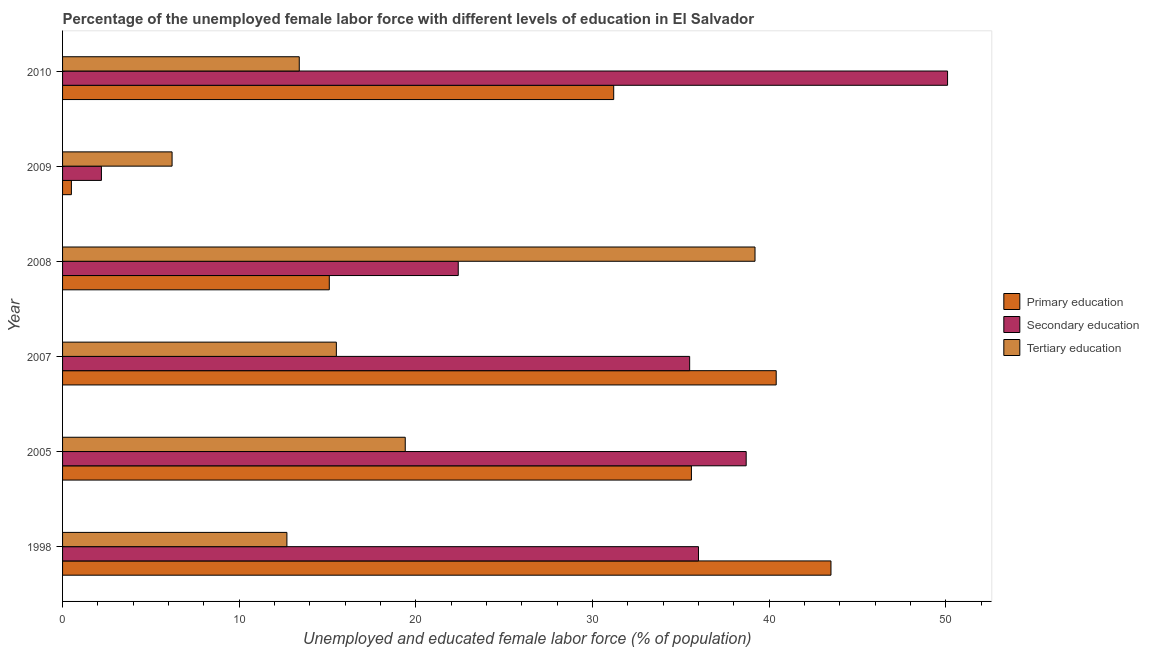Are the number of bars per tick equal to the number of legend labels?
Your response must be concise. Yes. How many bars are there on the 3rd tick from the top?
Provide a succinct answer. 3. What is the label of the 4th group of bars from the top?
Offer a very short reply. 2007. Across all years, what is the maximum percentage of female labor force who received tertiary education?
Provide a short and direct response. 39.2. Across all years, what is the minimum percentage of female labor force who received secondary education?
Provide a succinct answer. 2.2. What is the total percentage of female labor force who received primary education in the graph?
Your answer should be very brief. 166.3. What is the difference between the percentage of female labor force who received secondary education in 2010 and the percentage of female labor force who received tertiary education in 2005?
Make the answer very short. 30.7. What is the average percentage of female labor force who received tertiary education per year?
Your answer should be compact. 17.73. What is the ratio of the percentage of female labor force who received tertiary education in 1998 to that in 2008?
Your answer should be compact. 0.32. Is the percentage of female labor force who received tertiary education in 2009 less than that in 2010?
Give a very brief answer. Yes. Is the difference between the percentage of female labor force who received tertiary education in 2005 and 2008 greater than the difference between the percentage of female labor force who received primary education in 2005 and 2008?
Your response must be concise. No. What is the difference between the highest and the second highest percentage of female labor force who received tertiary education?
Offer a very short reply. 19.8. In how many years, is the percentage of female labor force who received tertiary education greater than the average percentage of female labor force who received tertiary education taken over all years?
Provide a succinct answer. 2. Is the sum of the percentage of female labor force who received primary education in 2008 and 2009 greater than the maximum percentage of female labor force who received tertiary education across all years?
Your answer should be compact. No. What does the 2nd bar from the bottom in 2005 represents?
Make the answer very short. Secondary education. Is it the case that in every year, the sum of the percentage of female labor force who received primary education and percentage of female labor force who received secondary education is greater than the percentage of female labor force who received tertiary education?
Your response must be concise. No. Are all the bars in the graph horizontal?
Give a very brief answer. Yes. What is the difference between two consecutive major ticks on the X-axis?
Your answer should be compact. 10. Are the values on the major ticks of X-axis written in scientific E-notation?
Make the answer very short. No. Does the graph contain any zero values?
Your answer should be very brief. No. Does the graph contain grids?
Provide a succinct answer. No. How many legend labels are there?
Your answer should be compact. 3. How are the legend labels stacked?
Your response must be concise. Vertical. What is the title of the graph?
Your response must be concise. Percentage of the unemployed female labor force with different levels of education in El Salvador. What is the label or title of the X-axis?
Keep it short and to the point. Unemployed and educated female labor force (% of population). What is the label or title of the Y-axis?
Provide a short and direct response. Year. What is the Unemployed and educated female labor force (% of population) in Primary education in 1998?
Your answer should be very brief. 43.5. What is the Unemployed and educated female labor force (% of population) of Tertiary education in 1998?
Your answer should be compact. 12.7. What is the Unemployed and educated female labor force (% of population) of Primary education in 2005?
Your answer should be very brief. 35.6. What is the Unemployed and educated female labor force (% of population) of Secondary education in 2005?
Your answer should be compact. 38.7. What is the Unemployed and educated female labor force (% of population) in Tertiary education in 2005?
Ensure brevity in your answer.  19.4. What is the Unemployed and educated female labor force (% of population) in Primary education in 2007?
Your answer should be compact. 40.4. What is the Unemployed and educated female labor force (% of population) of Secondary education in 2007?
Your answer should be very brief. 35.5. What is the Unemployed and educated female labor force (% of population) in Tertiary education in 2007?
Your answer should be very brief. 15.5. What is the Unemployed and educated female labor force (% of population) of Primary education in 2008?
Your answer should be very brief. 15.1. What is the Unemployed and educated female labor force (% of population) in Secondary education in 2008?
Your answer should be very brief. 22.4. What is the Unemployed and educated female labor force (% of population) in Tertiary education in 2008?
Provide a short and direct response. 39.2. What is the Unemployed and educated female labor force (% of population) of Primary education in 2009?
Ensure brevity in your answer.  0.5. What is the Unemployed and educated female labor force (% of population) of Secondary education in 2009?
Keep it short and to the point. 2.2. What is the Unemployed and educated female labor force (% of population) of Tertiary education in 2009?
Your response must be concise. 6.2. What is the Unemployed and educated female labor force (% of population) in Primary education in 2010?
Provide a succinct answer. 31.2. What is the Unemployed and educated female labor force (% of population) of Secondary education in 2010?
Your answer should be very brief. 50.1. What is the Unemployed and educated female labor force (% of population) in Tertiary education in 2010?
Offer a very short reply. 13.4. Across all years, what is the maximum Unemployed and educated female labor force (% of population) in Primary education?
Your answer should be compact. 43.5. Across all years, what is the maximum Unemployed and educated female labor force (% of population) in Secondary education?
Ensure brevity in your answer.  50.1. Across all years, what is the maximum Unemployed and educated female labor force (% of population) of Tertiary education?
Your response must be concise. 39.2. Across all years, what is the minimum Unemployed and educated female labor force (% of population) of Secondary education?
Provide a short and direct response. 2.2. Across all years, what is the minimum Unemployed and educated female labor force (% of population) in Tertiary education?
Provide a short and direct response. 6.2. What is the total Unemployed and educated female labor force (% of population) in Primary education in the graph?
Keep it short and to the point. 166.3. What is the total Unemployed and educated female labor force (% of population) in Secondary education in the graph?
Your answer should be compact. 184.9. What is the total Unemployed and educated female labor force (% of population) of Tertiary education in the graph?
Offer a terse response. 106.4. What is the difference between the Unemployed and educated female labor force (% of population) in Primary education in 1998 and that in 2005?
Offer a very short reply. 7.9. What is the difference between the Unemployed and educated female labor force (% of population) of Tertiary education in 1998 and that in 2005?
Provide a succinct answer. -6.7. What is the difference between the Unemployed and educated female labor force (% of population) in Primary education in 1998 and that in 2007?
Keep it short and to the point. 3.1. What is the difference between the Unemployed and educated female labor force (% of population) in Secondary education in 1998 and that in 2007?
Your answer should be very brief. 0.5. What is the difference between the Unemployed and educated female labor force (% of population) in Tertiary education in 1998 and that in 2007?
Your answer should be very brief. -2.8. What is the difference between the Unemployed and educated female labor force (% of population) of Primary education in 1998 and that in 2008?
Your response must be concise. 28.4. What is the difference between the Unemployed and educated female labor force (% of population) in Tertiary education in 1998 and that in 2008?
Provide a succinct answer. -26.5. What is the difference between the Unemployed and educated female labor force (% of population) in Secondary education in 1998 and that in 2009?
Offer a terse response. 33.8. What is the difference between the Unemployed and educated female labor force (% of population) in Tertiary education in 1998 and that in 2009?
Provide a short and direct response. 6.5. What is the difference between the Unemployed and educated female labor force (% of population) of Secondary education in 1998 and that in 2010?
Keep it short and to the point. -14.1. What is the difference between the Unemployed and educated female labor force (% of population) in Tertiary education in 1998 and that in 2010?
Your answer should be compact. -0.7. What is the difference between the Unemployed and educated female labor force (% of population) in Secondary education in 2005 and that in 2007?
Your answer should be very brief. 3.2. What is the difference between the Unemployed and educated female labor force (% of population) in Tertiary education in 2005 and that in 2008?
Offer a very short reply. -19.8. What is the difference between the Unemployed and educated female labor force (% of population) in Primary education in 2005 and that in 2009?
Keep it short and to the point. 35.1. What is the difference between the Unemployed and educated female labor force (% of population) of Secondary education in 2005 and that in 2009?
Give a very brief answer. 36.5. What is the difference between the Unemployed and educated female labor force (% of population) of Tertiary education in 2005 and that in 2009?
Ensure brevity in your answer.  13.2. What is the difference between the Unemployed and educated female labor force (% of population) of Primary education in 2005 and that in 2010?
Your response must be concise. 4.4. What is the difference between the Unemployed and educated female labor force (% of population) in Tertiary education in 2005 and that in 2010?
Offer a terse response. 6. What is the difference between the Unemployed and educated female labor force (% of population) of Primary education in 2007 and that in 2008?
Give a very brief answer. 25.3. What is the difference between the Unemployed and educated female labor force (% of population) of Secondary education in 2007 and that in 2008?
Your response must be concise. 13.1. What is the difference between the Unemployed and educated female labor force (% of population) in Tertiary education in 2007 and that in 2008?
Make the answer very short. -23.7. What is the difference between the Unemployed and educated female labor force (% of population) in Primary education in 2007 and that in 2009?
Provide a succinct answer. 39.9. What is the difference between the Unemployed and educated female labor force (% of population) of Secondary education in 2007 and that in 2009?
Make the answer very short. 33.3. What is the difference between the Unemployed and educated female labor force (% of population) of Tertiary education in 2007 and that in 2009?
Ensure brevity in your answer.  9.3. What is the difference between the Unemployed and educated female labor force (% of population) of Primary education in 2007 and that in 2010?
Offer a very short reply. 9.2. What is the difference between the Unemployed and educated female labor force (% of population) in Secondary education in 2007 and that in 2010?
Provide a succinct answer. -14.6. What is the difference between the Unemployed and educated female labor force (% of population) in Tertiary education in 2007 and that in 2010?
Keep it short and to the point. 2.1. What is the difference between the Unemployed and educated female labor force (% of population) of Secondary education in 2008 and that in 2009?
Provide a short and direct response. 20.2. What is the difference between the Unemployed and educated female labor force (% of population) of Tertiary education in 2008 and that in 2009?
Provide a succinct answer. 33. What is the difference between the Unemployed and educated female labor force (% of population) in Primary education in 2008 and that in 2010?
Ensure brevity in your answer.  -16.1. What is the difference between the Unemployed and educated female labor force (% of population) in Secondary education in 2008 and that in 2010?
Ensure brevity in your answer.  -27.7. What is the difference between the Unemployed and educated female labor force (% of population) of Tertiary education in 2008 and that in 2010?
Keep it short and to the point. 25.8. What is the difference between the Unemployed and educated female labor force (% of population) of Primary education in 2009 and that in 2010?
Provide a short and direct response. -30.7. What is the difference between the Unemployed and educated female labor force (% of population) of Secondary education in 2009 and that in 2010?
Your answer should be compact. -47.9. What is the difference between the Unemployed and educated female labor force (% of population) in Tertiary education in 2009 and that in 2010?
Give a very brief answer. -7.2. What is the difference between the Unemployed and educated female labor force (% of population) of Primary education in 1998 and the Unemployed and educated female labor force (% of population) of Tertiary education in 2005?
Make the answer very short. 24.1. What is the difference between the Unemployed and educated female labor force (% of population) in Secondary education in 1998 and the Unemployed and educated female labor force (% of population) in Tertiary education in 2005?
Make the answer very short. 16.6. What is the difference between the Unemployed and educated female labor force (% of population) of Primary education in 1998 and the Unemployed and educated female labor force (% of population) of Secondary education in 2008?
Your response must be concise. 21.1. What is the difference between the Unemployed and educated female labor force (% of population) of Primary education in 1998 and the Unemployed and educated female labor force (% of population) of Secondary education in 2009?
Your answer should be compact. 41.3. What is the difference between the Unemployed and educated female labor force (% of population) of Primary education in 1998 and the Unemployed and educated female labor force (% of population) of Tertiary education in 2009?
Your answer should be very brief. 37.3. What is the difference between the Unemployed and educated female labor force (% of population) in Secondary education in 1998 and the Unemployed and educated female labor force (% of population) in Tertiary education in 2009?
Your response must be concise. 29.8. What is the difference between the Unemployed and educated female labor force (% of population) in Primary education in 1998 and the Unemployed and educated female labor force (% of population) in Tertiary education in 2010?
Offer a very short reply. 30.1. What is the difference between the Unemployed and educated female labor force (% of population) of Secondary education in 1998 and the Unemployed and educated female labor force (% of population) of Tertiary education in 2010?
Give a very brief answer. 22.6. What is the difference between the Unemployed and educated female labor force (% of population) of Primary education in 2005 and the Unemployed and educated female labor force (% of population) of Secondary education in 2007?
Give a very brief answer. 0.1. What is the difference between the Unemployed and educated female labor force (% of population) of Primary education in 2005 and the Unemployed and educated female labor force (% of population) of Tertiary education in 2007?
Make the answer very short. 20.1. What is the difference between the Unemployed and educated female labor force (% of population) of Secondary education in 2005 and the Unemployed and educated female labor force (% of population) of Tertiary education in 2007?
Provide a succinct answer. 23.2. What is the difference between the Unemployed and educated female labor force (% of population) in Primary education in 2005 and the Unemployed and educated female labor force (% of population) in Secondary education in 2008?
Your answer should be compact. 13.2. What is the difference between the Unemployed and educated female labor force (% of population) in Primary education in 2005 and the Unemployed and educated female labor force (% of population) in Tertiary education in 2008?
Offer a very short reply. -3.6. What is the difference between the Unemployed and educated female labor force (% of population) in Primary education in 2005 and the Unemployed and educated female labor force (% of population) in Secondary education in 2009?
Your answer should be very brief. 33.4. What is the difference between the Unemployed and educated female labor force (% of population) in Primary education in 2005 and the Unemployed and educated female labor force (% of population) in Tertiary education in 2009?
Ensure brevity in your answer.  29.4. What is the difference between the Unemployed and educated female labor force (% of population) in Secondary education in 2005 and the Unemployed and educated female labor force (% of population) in Tertiary education in 2009?
Your answer should be very brief. 32.5. What is the difference between the Unemployed and educated female labor force (% of population) in Primary education in 2005 and the Unemployed and educated female labor force (% of population) in Tertiary education in 2010?
Keep it short and to the point. 22.2. What is the difference between the Unemployed and educated female labor force (% of population) in Secondary education in 2005 and the Unemployed and educated female labor force (% of population) in Tertiary education in 2010?
Offer a very short reply. 25.3. What is the difference between the Unemployed and educated female labor force (% of population) in Primary education in 2007 and the Unemployed and educated female labor force (% of population) in Secondary education in 2008?
Ensure brevity in your answer.  18. What is the difference between the Unemployed and educated female labor force (% of population) of Primary education in 2007 and the Unemployed and educated female labor force (% of population) of Secondary education in 2009?
Your answer should be very brief. 38.2. What is the difference between the Unemployed and educated female labor force (% of population) in Primary education in 2007 and the Unemployed and educated female labor force (% of population) in Tertiary education in 2009?
Provide a short and direct response. 34.2. What is the difference between the Unemployed and educated female labor force (% of population) in Secondary education in 2007 and the Unemployed and educated female labor force (% of population) in Tertiary education in 2009?
Offer a terse response. 29.3. What is the difference between the Unemployed and educated female labor force (% of population) of Primary education in 2007 and the Unemployed and educated female labor force (% of population) of Secondary education in 2010?
Ensure brevity in your answer.  -9.7. What is the difference between the Unemployed and educated female labor force (% of population) in Primary education in 2007 and the Unemployed and educated female labor force (% of population) in Tertiary education in 2010?
Offer a terse response. 27. What is the difference between the Unemployed and educated female labor force (% of population) of Secondary education in 2007 and the Unemployed and educated female labor force (% of population) of Tertiary education in 2010?
Provide a short and direct response. 22.1. What is the difference between the Unemployed and educated female labor force (% of population) of Primary education in 2008 and the Unemployed and educated female labor force (% of population) of Tertiary education in 2009?
Keep it short and to the point. 8.9. What is the difference between the Unemployed and educated female labor force (% of population) in Primary education in 2008 and the Unemployed and educated female labor force (% of population) in Secondary education in 2010?
Give a very brief answer. -35. What is the difference between the Unemployed and educated female labor force (% of population) of Primary education in 2008 and the Unemployed and educated female labor force (% of population) of Tertiary education in 2010?
Keep it short and to the point. 1.7. What is the difference between the Unemployed and educated female labor force (% of population) of Primary education in 2009 and the Unemployed and educated female labor force (% of population) of Secondary education in 2010?
Keep it short and to the point. -49.6. What is the average Unemployed and educated female labor force (% of population) of Primary education per year?
Offer a terse response. 27.72. What is the average Unemployed and educated female labor force (% of population) in Secondary education per year?
Ensure brevity in your answer.  30.82. What is the average Unemployed and educated female labor force (% of population) of Tertiary education per year?
Ensure brevity in your answer.  17.73. In the year 1998, what is the difference between the Unemployed and educated female labor force (% of population) of Primary education and Unemployed and educated female labor force (% of population) of Secondary education?
Provide a short and direct response. 7.5. In the year 1998, what is the difference between the Unemployed and educated female labor force (% of population) in Primary education and Unemployed and educated female labor force (% of population) in Tertiary education?
Offer a very short reply. 30.8. In the year 1998, what is the difference between the Unemployed and educated female labor force (% of population) of Secondary education and Unemployed and educated female labor force (% of population) of Tertiary education?
Provide a succinct answer. 23.3. In the year 2005, what is the difference between the Unemployed and educated female labor force (% of population) in Secondary education and Unemployed and educated female labor force (% of population) in Tertiary education?
Keep it short and to the point. 19.3. In the year 2007, what is the difference between the Unemployed and educated female labor force (% of population) of Primary education and Unemployed and educated female labor force (% of population) of Secondary education?
Ensure brevity in your answer.  4.9. In the year 2007, what is the difference between the Unemployed and educated female labor force (% of population) of Primary education and Unemployed and educated female labor force (% of population) of Tertiary education?
Give a very brief answer. 24.9. In the year 2008, what is the difference between the Unemployed and educated female labor force (% of population) of Primary education and Unemployed and educated female labor force (% of population) of Secondary education?
Your answer should be compact. -7.3. In the year 2008, what is the difference between the Unemployed and educated female labor force (% of population) in Primary education and Unemployed and educated female labor force (% of population) in Tertiary education?
Keep it short and to the point. -24.1. In the year 2008, what is the difference between the Unemployed and educated female labor force (% of population) in Secondary education and Unemployed and educated female labor force (% of population) in Tertiary education?
Provide a succinct answer. -16.8. In the year 2009, what is the difference between the Unemployed and educated female labor force (% of population) in Secondary education and Unemployed and educated female labor force (% of population) in Tertiary education?
Offer a terse response. -4. In the year 2010, what is the difference between the Unemployed and educated female labor force (% of population) of Primary education and Unemployed and educated female labor force (% of population) of Secondary education?
Ensure brevity in your answer.  -18.9. In the year 2010, what is the difference between the Unemployed and educated female labor force (% of population) of Secondary education and Unemployed and educated female labor force (% of population) of Tertiary education?
Your answer should be compact. 36.7. What is the ratio of the Unemployed and educated female labor force (% of population) in Primary education in 1998 to that in 2005?
Your answer should be very brief. 1.22. What is the ratio of the Unemployed and educated female labor force (% of population) of Secondary education in 1998 to that in 2005?
Ensure brevity in your answer.  0.93. What is the ratio of the Unemployed and educated female labor force (% of population) in Tertiary education in 1998 to that in 2005?
Keep it short and to the point. 0.65. What is the ratio of the Unemployed and educated female labor force (% of population) in Primary education in 1998 to that in 2007?
Your response must be concise. 1.08. What is the ratio of the Unemployed and educated female labor force (% of population) of Secondary education in 1998 to that in 2007?
Offer a very short reply. 1.01. What is the ratio of the Unemployed and educated female labor force (% of population) in Tertiary education in 1998 to that in 2007?
Keep it short and to the point. 0.82. What is the ratio of the Unemployed and educated female labor force (% of population) of Primary education in 1998 to that in 2008?
Keep it short and to the point. 2.88. What is the ratio of the Unemployed and educated female labor force (% of population) of Secondary education in 1998 to that in 2008?
Give a very brief answer. 1.61. What is the ratio of the Unemployed and educated female labor force (% of population) of Tertiary education in 1998 to that in 2008?
Make the answer very short. 0.32. What is the ratio of the Unemployed and educated female labor force (% of population) in Secondary education in 1998 to that in 2009?
Provide a short and direct response. 16.36. What is the ratio of the Unemployed and educated female labor force (% of population) in Tertiary education in 1998 to that in 2009?
Your answer should be compact. 2.05. What is the ratio of the Unemployed and educated female labor force (% of population) of Primary education in 1998 to that in 2010?
Ensure brevity in your answer.  1.39. What is the ratio of the Unemployed and educated female labor force (% of population) of Secondary education in 1998 to that in 2010?
Make the answer very short. 0.72. What is the ratio of the Unemployed and educated female labor force (% of population) in Tertiary education in 1998 to that in 2010?
Provide a succinct answer. 0.95. What is the ratio of the Unemployed and educated female labor force (% of population) in Primary education in 2005 to that in 2007?
Give a very brief answer. 0.88. What is the ratio of the Unemployed and educated female labor force (% of population) in Secondary education in 2005 to that in 2007?
Your response must be concise. 1.09. What is the ratio of the Unemployed and educated female labor force (% of population) in Tertiary education in 2005 to that in 2007?
Offer a very short reply. 1.25. What is the ratio of the Unemployed and educated female labor force (% of population) of Primary education in 2005 to that in 2008?
Offer a very short reply. 2.36. What is the ratio of the Unemployed and educated female labor force (% of population) of Secondary education in 2005 to that in 2008?
Offer a terse response. 1.73. What is the ratio of the Unemployed and educated female labor force (% of population) in Tertiary education in 2005 to that in 2008?
Ensure brevity in your answer.  0.49. What is the ratio of the Unemployed and educated female labor force (% of population) of Primary education in 2005 to that in 2009?
Keep it short and to the point. 71.2. What is the ratio of the Unemployed and educated female labor force (% of population) of Secondary education in 2005 to that in 2009?
Offer a terse response. 17.59. What is the ratio of the Unemployed and educated female labor force (% of population) of Tertiary education in 2005 to that in 2009?
Make the answer very short. 3.13. What is the ratio of the Unemployed and educated female labor force (% of population) in Primary education in 2005 to that in 2010?
Your response must be concise. 1.14. What is the ratio of the Unemployed and educated female labor force (% of population) in Secondary education in 2005 to that in 2010?
Give a very brief answer. 0.77. What is the ratio of the Unemployed and educated female labor force (% of population) in Tertiary education in 2005 to that in 2010?
Keep it short and to the point. 1.45. What is the ratio of the Unemployed and educated female labor force (% of population) in Primary education in 2007 to that in 2008?
Your answer should be compact. 2.68. What is the ratio of the Unemployed and educated female labor force (% of population) in Secondary education in 2007 to that in 2008?
Offer a terse response. 1.58. What is the ratio of the Unemployed and educated female labor force (% of population) in Tertiary education in 2007 to that in 2008?
Give a very brief answer. 0.4. What is the ratio of the Unemployed and educated female labor force (% of population) in Primary education in 2007 to that in 2009?
Your answer should be very brief. 80.8. What is the ratio of the Unemployed and educated female labor force (% of population) of Secondary education in 2007 to that in 2009?
Provide a short and direct response. 16.14. What is the ratio of the Unemployed and educated female labor force (% of population) in Primary education in 2007 to that in 2010?
Ensure brevity in your answer.  1.29. What is the ratio of the Unemployed and educated female labor force (% of population) in Secondary education in 2007 to that in 2010?
Make the answer very short. 0.71. What is the ratio of the Unemployed and educated female labor force (% of population) in Tertiary education in 2007 to that in 2010?
Make the answer very short. 1.16. What is the ratio of the Unemployed and educated female labor force (% of population) of Primary education in 2008 to that in 2009?
Provide a short and direct response. 30.2. What is the ratio of the Unemployed and educated female labor force (% of population) of Secondary education in 2008 to that in 2009?
Your answer should be very brief. 10.18. What is the ratio of the Unemployed and educated female labor force (% of population) in Tertiary education in 2008 to that in 2009?
Your answer should be very brief. 6.32. What is the ratio of the Unemployed and educated female labor force (% of population) of Primary education in 2008 to that in 2010?
Keep it short and to the point. 0.48. What is the ratio of the Unemployed and educated female labor force (% of population) in Secondary education in 2008 to that in 2010?
Your answer should be very brief. 0.45. What is the ratio of the Unemployed and educated female labor force (% of population) of Tertiary education in 2008 to that in 2010?
Offer a terse response. 2.93. What is the ratio of the Unemployed and educated female labor force (% of population) of Primary education in 2009 to that in 2010?
Offer a very short reply. 0.02. What is the ratio of the Unemployed and educated female labor force (% of population) of Secondary education in 2009 to that in 2010?
Offer a very short reply. 0.04. What is the ratio of the Unemployed and educated female labor force (% of population) in Tertiary education in 2009 to that in 2010?
Your response must be concise. 0.46. What is the difference between the highest and the second highest Unemployed and educated female labor force (% of population) in Primary education?
Make the answer very short. 3.1. What is the difference between the highest and the second highest Unemployed and educated female labor force (% of population) of Secondary education?
Offer a terse response. 11.4. What is the difference between the highest and the second highest Unemployed and educated female labor force (% of population) in Tertiary education?
Provide a short and direct response. 19.8. What is the difference between the highest and the lowest Unemployed and educated female labor force (% of population) of Secondary education?
Give a very brief answer. 47.9. What is the difference between the highest and the lowest Unemployed and educated female labor force (% of population) of Tertiary education?
Offer a terse response. 33. 